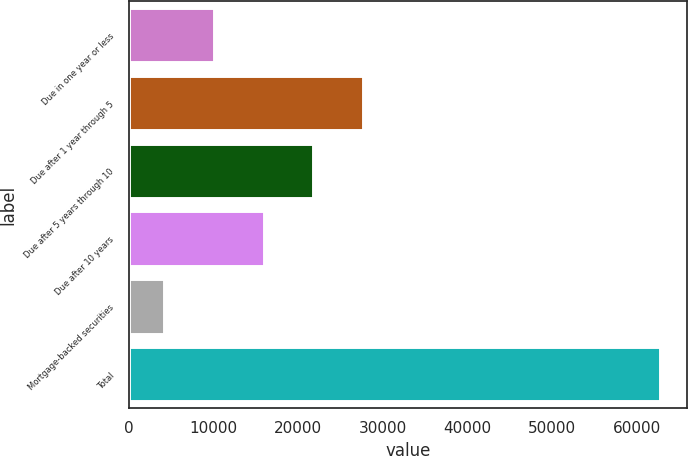Convert chart. <chart><loc_0><loc_0><loc_500><loc_500><bar_chart><fcel>Due in one year or less<fcel>Due after 1 year through 5<fcel>Due after 5 years through 10<fcel>Due after 10 years<fcel>Mortgage-backed securities<fcel>Total<nl><fcel>10029.6<fcel>27626.4<fcel>21760.8<fcel>15895.2<fcel>4164<fcel>62820<nl></chart> 